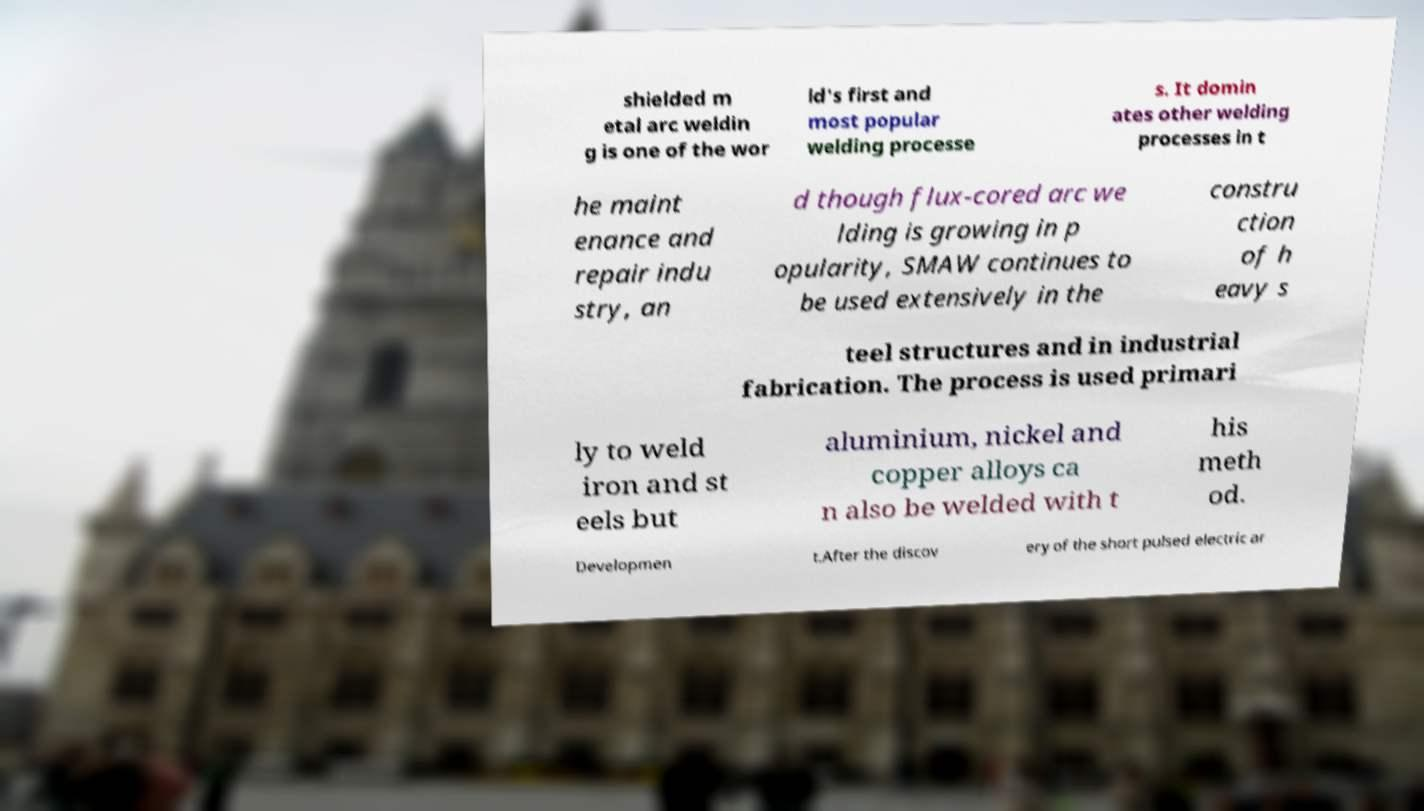Could you assist in decoding the text presented in this image and type it out clearly? shielded m etal arc weldin g is one of the wor ld's first and most popular welding processe s. It domin ates other welding processes in t he maint enance and repair indu stry, an d though flux-cored arc we lding is growing in p opularity, SMAW continues to be used extensively in the constru ction of h eavy s teel structures and in industrial fabrication. The process is used primari ly to weld iron and st eels but aluminium, nickel and copper alloys ca n also be welded with t his meth od. Developmen t.After the discov ery of the short pulsed electric ar 